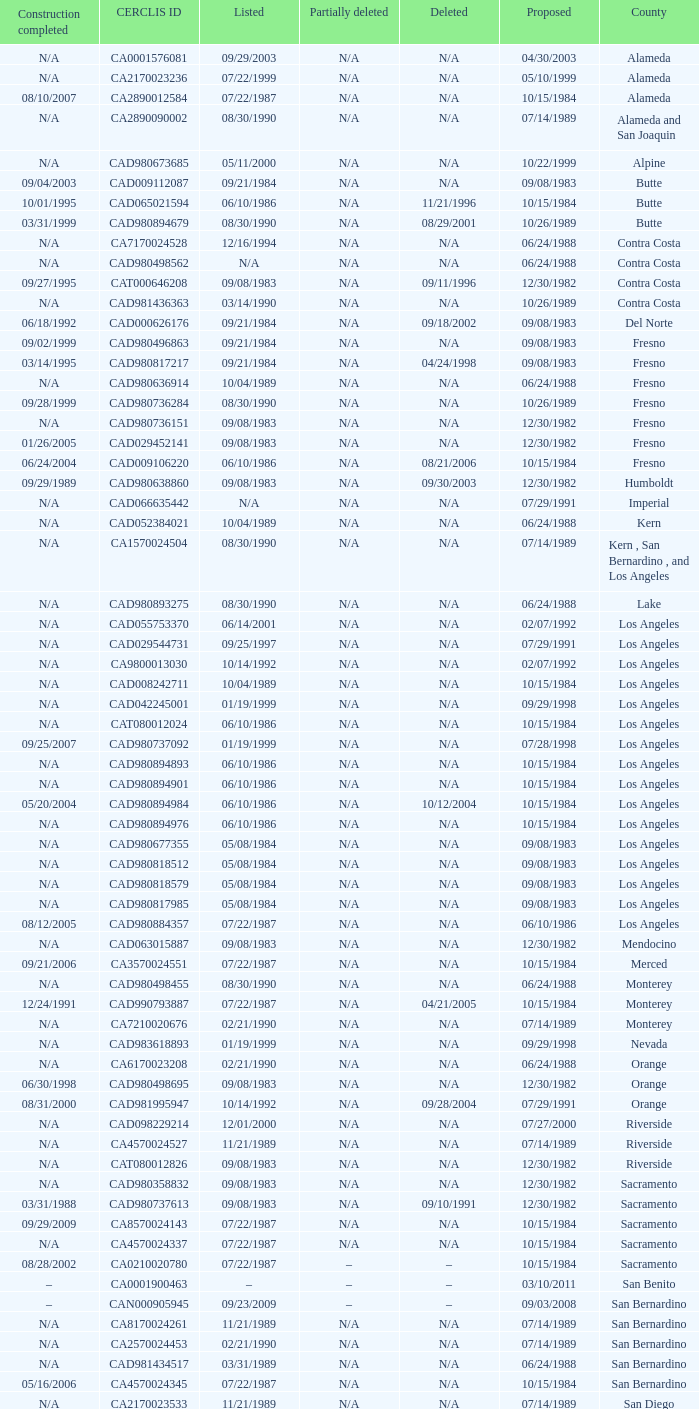What construction completed on 08/10/2007? 07/22/1987. 